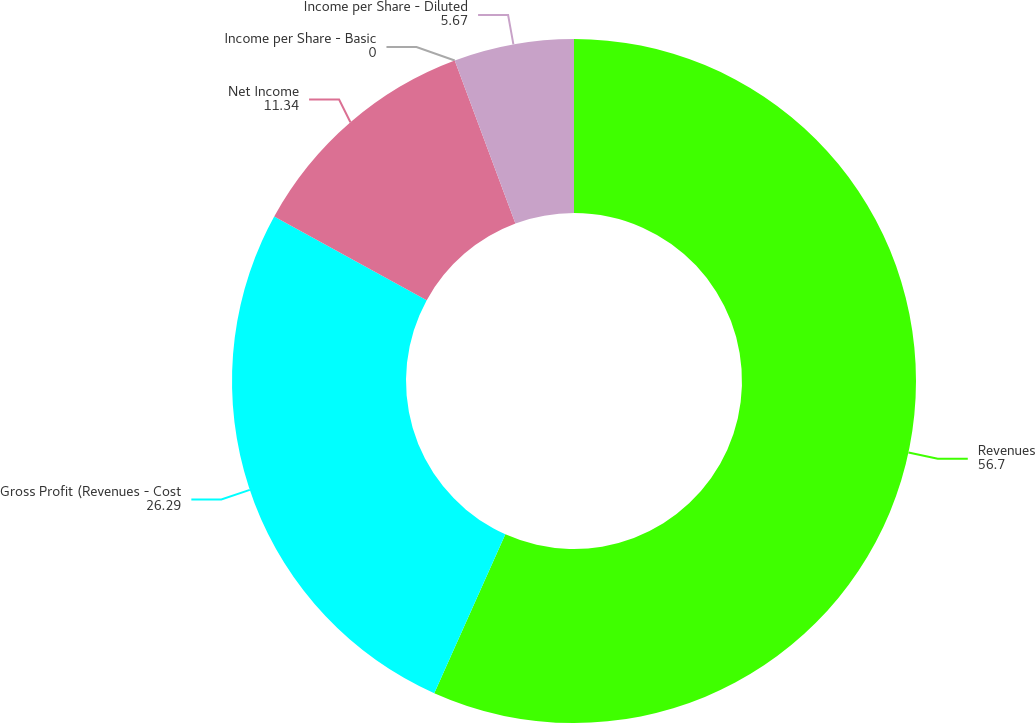<chart> <loc_0><loc_0><loc_500><loc_500><pie_chart><fcel>Revenues<fcel>Gross Profit (Revenues - Cost<fcel>Net Income<fcel>Income per Share - Basic<fcel>Income per Share - Diluted<nl><fcel>56.7%<fcel>26.29%<fcel>11.34%<fcel>0.0%<fcel>5.67%<nl></chart> 